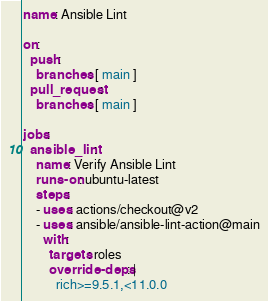Convert code to text. <code><loc_0><loc_0><loc_500><loc_500><_YAML_>name: Ansible Lint

on:
  push:
    branches: [ main ]
  pull_request:
    branches: [ main ]

jobs:
  ansible_lint:
    name: Verify Ansible Lint
    runs-on: ubuntu-latest
    steps:
    - uses: actions/checkout@v2
    - uses: ansible/ansible-lint-action@main
      with:
        targets: roles
        override-deps: |
          rich>=9.5.1,<11.0.0
</code> 